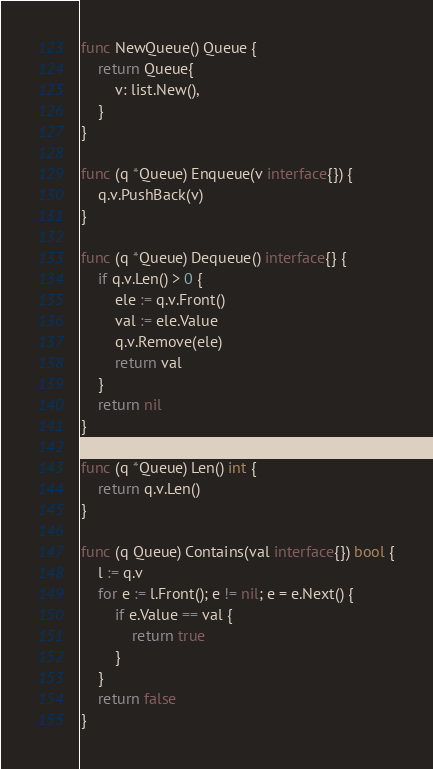Convert code to text. <code><loc_0><loc_0><loc_500><loc_500><_Go_>func NewQueue() Queue {
	return Queue{
		v: list.New(),
	}
}

func (q *Queue) Enqueue(v interface{}) {
	q.v.PushBack(v)
}

func (q *Queue) Dequeue() interface{} {
	if q.v.Len() > 0 {
		ele := q.v.Front()
		val := ele.Value
		q.v.Remove(ele)
		return val
	}
	return nil
}

func (q *Queue) Len() int {
	return q.v.Len()
}

func (q Queue) Contains(val interface{}) bool {
	l := q.v
	for e := l.Front(); e != nil; e = e.Next() {
		if e.Value == val {
			return true
		}
	}
	return false
}
</code> 